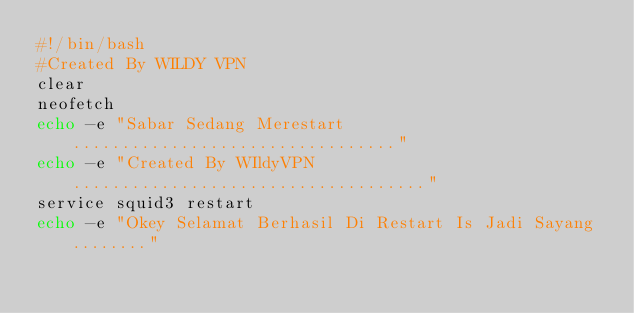Convert code to text. <code><loc_0><loc_0><loc_500><loc_500><_Bash_>#!/bin/bash
#Created By WILDY VPN
clear
neofetch
echo -e "Sabar Sedang Merestart................................."
echo -e "Created By WIldyVPN...................................."
service squid3 restart
echo -e "Okey Selamat Berhasil Di Restart Is Jadi Sayang........"
</code> 